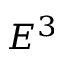Convert formula to latex. <formula><loc_0><loc_0><loc_500><loc_500>E ^ { 3 }</formula> 